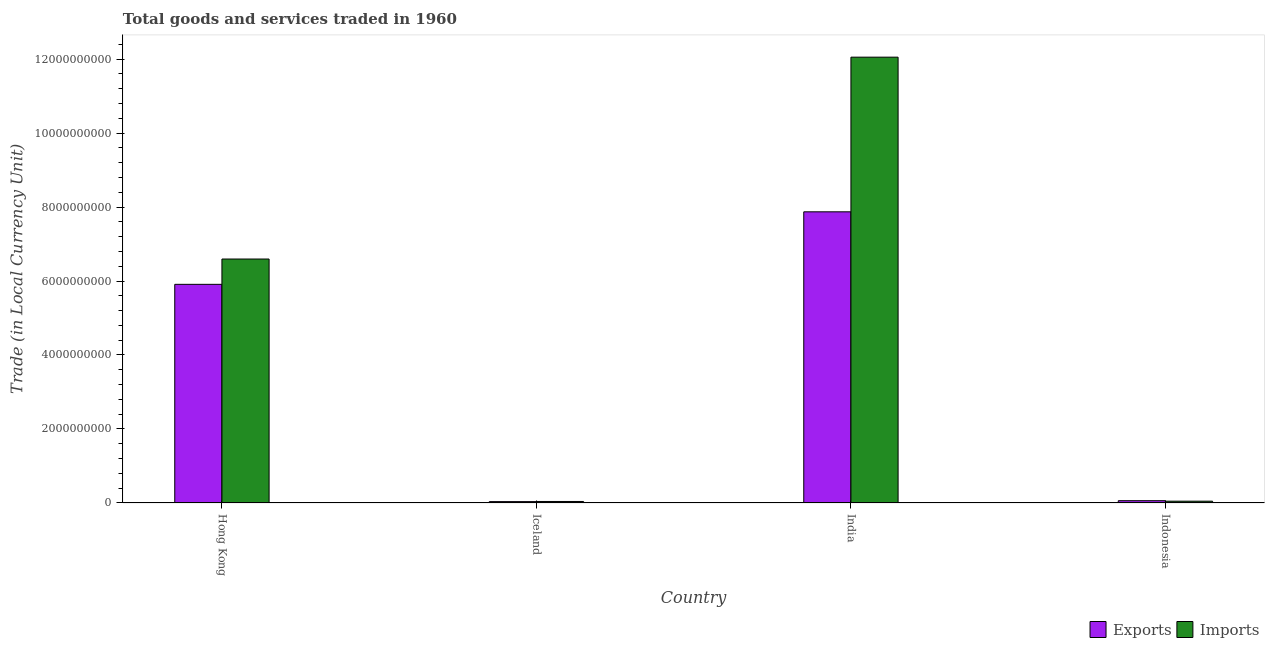How many groups of bars are there?
Keep it short and to the point. 4. Are the number of bars per tick equal to the number of legend labels?
Make the answer very short. Yes. How many bars are there on the 1st tick from the left?
Ensure brevity in your answer.  2. In how many cases, is the number of bars for a given country not equal to the number of legend labels?
Provide a short and direct response. 0. What is the imports of goods and services in Indonesia?
Give a very brief answer. 4.90e+07. Across all countries, what is the maximum export of goods and services?
Keep it short and to the point. 7.87e+09. Across all countries, what is the minimum export of goods and services?
Provide a short and direct response. 3.71e+07. In which country was the export of goods and services maximum?
Provide a short and direct response. India. What is the total imports of goods and services in the graph?
Offer a very short reply. 1.87e+1. What is the difference between the imports of goods and services in Hong Kong and that in Iceland?
Offer a very short reply. 6.55e+09. What is the difference between the export of goods and services in Iceland and the imports of goods and services in India?
Offer a very short reply. -1.20e+1. What is the average export of goods and services per country?
Your answer should be compact. 3.47e+09. What is the difference between the imports of goods and services and export of goods and services in Iceland?
Provide a short and direct response. 3.84e+06. In how many countries, is the export of goods and services greater than 2400000000 LCU?
Offer a very short reply. 2. What is the ratio of the export of goods and services in India to that in Indonesia?
Keep it short and to the point. 126.97. Is the imports of goods and services in India less than that in Indonesia?
Your answer should be compact. No. What is the difference between the highest and the second highest export of goods and services?
Your answer should be compact. 1.96e+09. What is the difference between the highest and the lowest export of goods and services?
Provide a short and direct response. 7.83e+09. In how many countries, is the imports of goods and services greater than the average imports of goods and services taken over all countries?
Offer a terse response. 2. What does the 1st bar from the left in Indonesia represents?
Your answer should be very brief. Exports. What does the 1st bar from the right in Hong Kong represents?
Provide a short and direct response. Imports. Are all the bars in the graph horizontal?
Your answer should be compact. No. How many countries are there in the graph?
Give a very brief answer. 4. What is the difference between two consecutive major ticks on the Y-axis?
Make the answer very short. 2.00e+09. Are the values on the major ticks of Y-axis written in scientific E-notation?
Ensure brevity in your answer.  No. What is the title of the graph?
Provide a short and direct response. Total goods and services traded in 1960. Does "Forest" appear as one of the legend labels in the graph?
Provide a short and direct response. No. What is the label or title of the X-axis?
Offer a terse response. Country. What is the label or title of the Y-axis?
Your response must be concise. Trade (in Local Currency Unit). What is the Trade (in Local Currency Unit) of Exports in Hong Kong?
Offer a terse response. 5.91e+09. What is the Trade (in Local Currency Unit) of Imports in Hong Kong?
Give a very brief answer. 6.59e+09. What is the Trade (in Local Currency Unit) of Exports in Iceland?
Provide a succinct answer. 3.71e+07. What is the Trade (in Local Currency Unit) of Imports in Iceland?
Offer a terse response. 4.10e+07. What is the Trade (in Local Currency Unit) of Exports in India?
Offer a terse response. 7.87e+09. What is the Trade (in Local Currency Unit) of Imports in India?
Ensure brevity in your answer.  1.20e+1. What is the Trade (in Local Currency Unit) of Exports in Indonesia?
Ensure brevity in your answer.  6.20e+07. What is the Trade (in Local Currency Unit) in Imports in Indonesia?
Ensure brevity in your answer.  4.90e+07. Across all countries, what is the maximum Trade (in Local Currency Unit) of Exports?
Offer a terse response. 7.87e+09. Across all countries, what is the maximum Trade (in Local Currency Unit) of Imports?
Provide a succinct answer. 1.20e+1. Across all countries, what is the minimum Trade (in Local Currency Unit) in Exports?
Offer a very short reply. 3.71e+07. Across all countries, what is the minimum Trade (in Local Currency Unit) in Imports?
Your answer should be very brief. 4.10e+07. What is the total Trade (in Local Currency Unit) in Exports in the graph?
Provide a succinct answer. 1.39e+1. What is the total Trade (in Local Currency Unit) of Imports in the graph?
Provide a succinct answer. 1.87e+1. What is the difference between the Trade (in Local Currency Unit) of Exports in Hong Kong and that in Iceland?
Ensure brevity in your answer.  5.87e+09. What is the difference between the Trade (in Local Currency Unit) in Imports in Hong Kong and that in Iceland?
Make the answer very short. 6.55e+09. What is the difference between the Trade (in Local Currency Unit) of Exports in Hong Kong and that in India?
Your answer should be very brief. -1.96e+09. What is the difference between the Trade (in Local Currency Unit) in Imports in Hong Kong and that in India?
Give a very brief answer. -5.46e+09. What is the difference between the Trade (in Local Currency Unit) in Exports in Hong Kong and that in Indonesia?
Provide a short and direct response. 5.85e+09. What is the difference between the Trade (in Local Currency Unit) of Imports in Hong Kong and that in Indonesia?
Keep it short and to the point. 6.55e+09. What is the difference between the Trade (in Local Currency Unit) of Exports in Iceland and that in India?
Your answer should be compact. -7.83e+09. What is the difference between the Trade (in Local Currency Unit) in Imports in Iceland and that in India?
Offer a terse response. -1.20e+1. What is the difference between the Trade (in Local Currency Unit) of Exports in Iceland and that in Indonesia?
Make the answer very short. -2.49e+07. What is the difference between the Trade (in Local Currency Unit) of Imports in Iceland and that in Indonesia?
Your answer should be compact. -8.04e+06. What is the difference between the Trade (in Local Currency Unit) of Exports in India and that in Indonesia?
Keep it short and to the point. 7.81e+09. What is the difference between the Trade (in Local Currency Unit) in Imports in India and that in Indonesia?
Give a very brief answer. 1.20e+1. What is the difference between the Trade (in Local Currency Unit) of Exports in Hong Kong and the Trade (in Local Currency Unit) of Imports in Iceland?
Make the answer very short. 5.87e+09. What is the difference between the Trade (in Local Currency Unit) in Exports in Hong Kong and the Trade (in Local Currency Unit) in Imports in India?
Your response must be concise. -6.14e+09. What is the difference between the Trade (in Local Currency Unit) of Exports in Hong Kong and the Trade (in Local Currency Unit) of Imports in Indonesia?
Keep it short and to the point. 5.86e+09. What is the difference between the Trade (in Local Currency Unit) of Exports in Iceland and the Trade (in Local Currency Unit) of Imports in India?
Your answer should be compact. -1.20e+1. What is the difference between the Trade (in Local Currency Unit) of Exports in Iceland and the Trade (in Local Currency Unit) of Imports in Indonesia?
Offer a very short reply. -1.19e+07. What is the difference between the Trade (in Local Currency Unit) of Exports in India and the Trade (in Local Currency Unit) of Imports in Indonesia?
Your response must be concise. 7.82e+09. What is the average Trade (in Local Currency Unit) in Exports per country?
Your answer should be compact. 3.47e+09. What is the average Trade (in Local Currency Unit) of Imports per country?
Ensure brevity in your answer.  4.68e+09. What is the difference between the Trade (in Local Currency Unit) in Exports and Trade (in Local Currency Unit) in Imports in Hong Kong?
Ensure brevity in your answer.  -6.84e+08. What is the difference between the Trade (in Local Currency Unit) of Exports and Trade (in Local Currency Unit) of Imports in Iceland?
Ensure brevity in your answer.  -3.84e+06. What is the difference between the Trade (in Local Currency Unit) of Exports and Trade (in Local Currency Unit) of Imports in India?
Keep it short and to the point. -4.18e+09. What is the difference between the Trade (in Local Currency Unit) in Exports and Trade (in Local Currency Unit) in Imports in Indonesia?
Provide a short and direct response. 1.30e+07. What is the ratio of the Trade (in Local Currency Unit) of Exports in Hong Kong to that in Iceland?
Provide a succinct answer. 159.23. What is the ratio of the Trade (in Local Currency Unit) in Imports in Hong Kong to that in Iceland?
Your response must be concise. 161. What is the ratio of the Trade (in Local Currency Unit) in Exports in Hong Kong to that in India?
Provide a short and direct response. 0.75. What is the ratio of the Trade (in Local Currency Unit) in Imports in Hong Kong to that in India?
Offer a terse response. 0.55. What is the ratio of the Trade (in Local Currency Unit) in Exports in Hong Kong to that in Indonesia?
Give a very brief answer. 95.35. What is the ratio of the Trade (in Local Currency Unit) of Imports in Hong Kong to that in Indonesia?
Give a very brief answer. 134.57. What is the ratio of the Trade (in Local Currency Unit) in Exports in Iceland to that in India?
Your answer should be very brief. 0. What is the ratio of the Trade (in Local Currency Unit) in Imports in Iceland to that in India?
Provide a short and direct response. 0. What is the ratio of the Trade (in Local Currency Unit) of Exports in Iceland to that in Indonesia?
Your answer should be very brief. 0.6. What is the ratio of the Trade (in Local Currency Unit) in Imports in Iceland to that in Indonesia?
Ensure brevity in your answer.  0.84. What is the ratio of the Trade (in Local Currency Unit) in Exports in India to that in Indonesia?
Make the answer very short. 126.97. What is the ratio of the Trade (in Local Currency Unit) of Imports in India to that in Indonesia?
Provide a succinct answer. 245.92. What is the difference between the highest and the second highest Trade (in Local Currency Unit) of Exports?
Ensure brevity in your answer.  1.96e+09. What is the difference between the highest and the second highest Trade (in Local Currency Unit) of Imports?
Offer a very short reply. 5.46e+09. What is the difference between the highest and the lowest Trade (in Local Currency Unit) in Exports?
Give a very brief answer. 7.83e+09. What is the difference between the highest and the lowest Trade (in Local Currency Unit) in Imports?
Your response must be concise. 1.20e+1. 